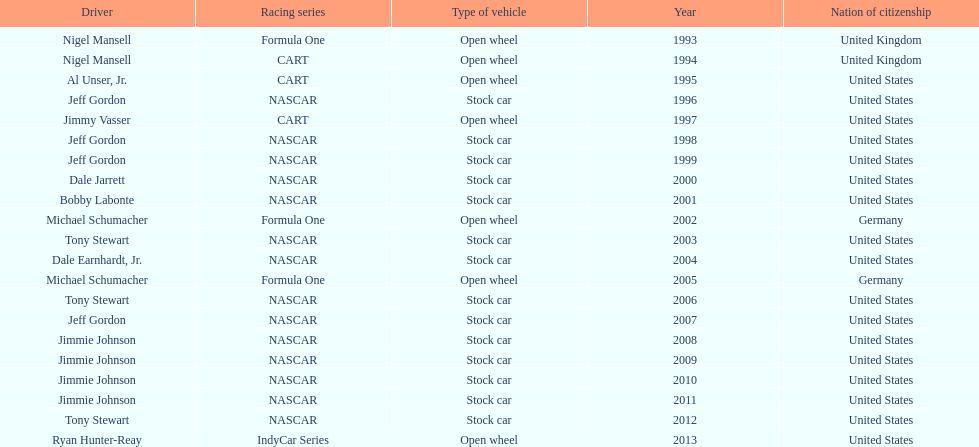Which driver secured espy awards with an 11-year gap between victories? Jeff Gordon. 